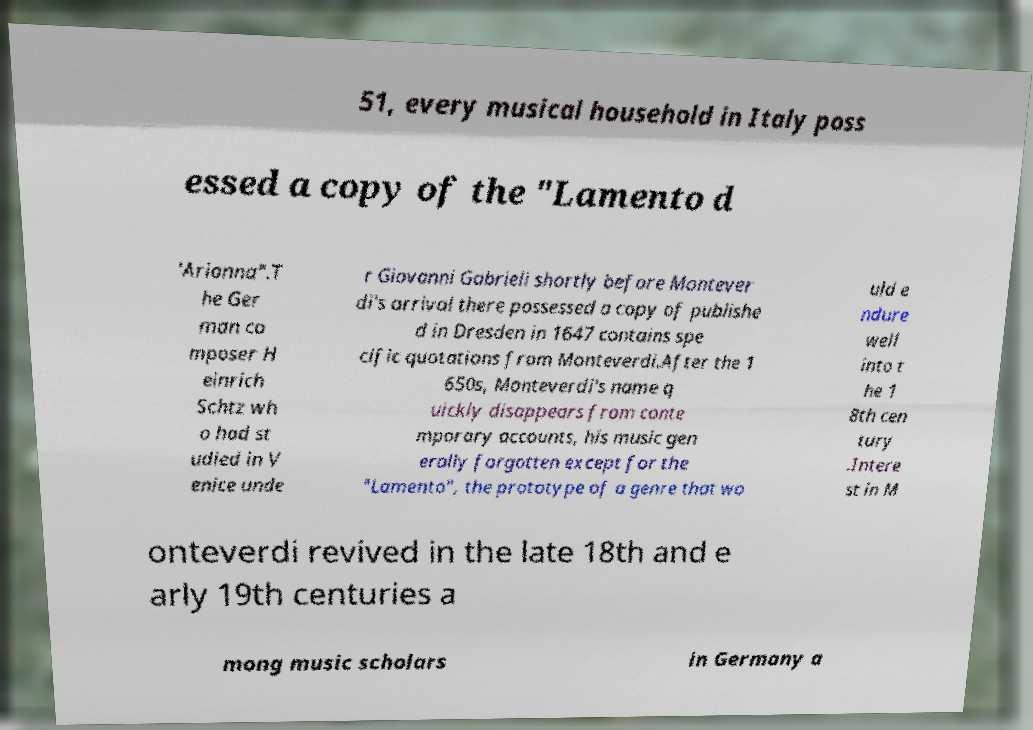There's text embedded in this image that I need extracted. Can you transcribe it verbatim? 51, every musical household in Italy poss essed a copy of the "Lamento d 'Arianna".T he Ger man co mposer H einrich Schtz wh o had st udied in V enice unde r Giovanni Gabrieli shortly before Montever di's arrival there possessed a copy of publishe d in Dresden in 1647 contains spe cific quotations from Monteverdi.After the 1 650s, Monteverdi's name q uickly disappears from conte mporary accounts, his music gen erally forgotten except for the "Lamento", the prototype of a genre that wo uld e ndure well into t he 1 8th cen tury .Intere st in M onteverdi revived in the late 18th and e arly 19th centuries a mong music scholars in Germany a 